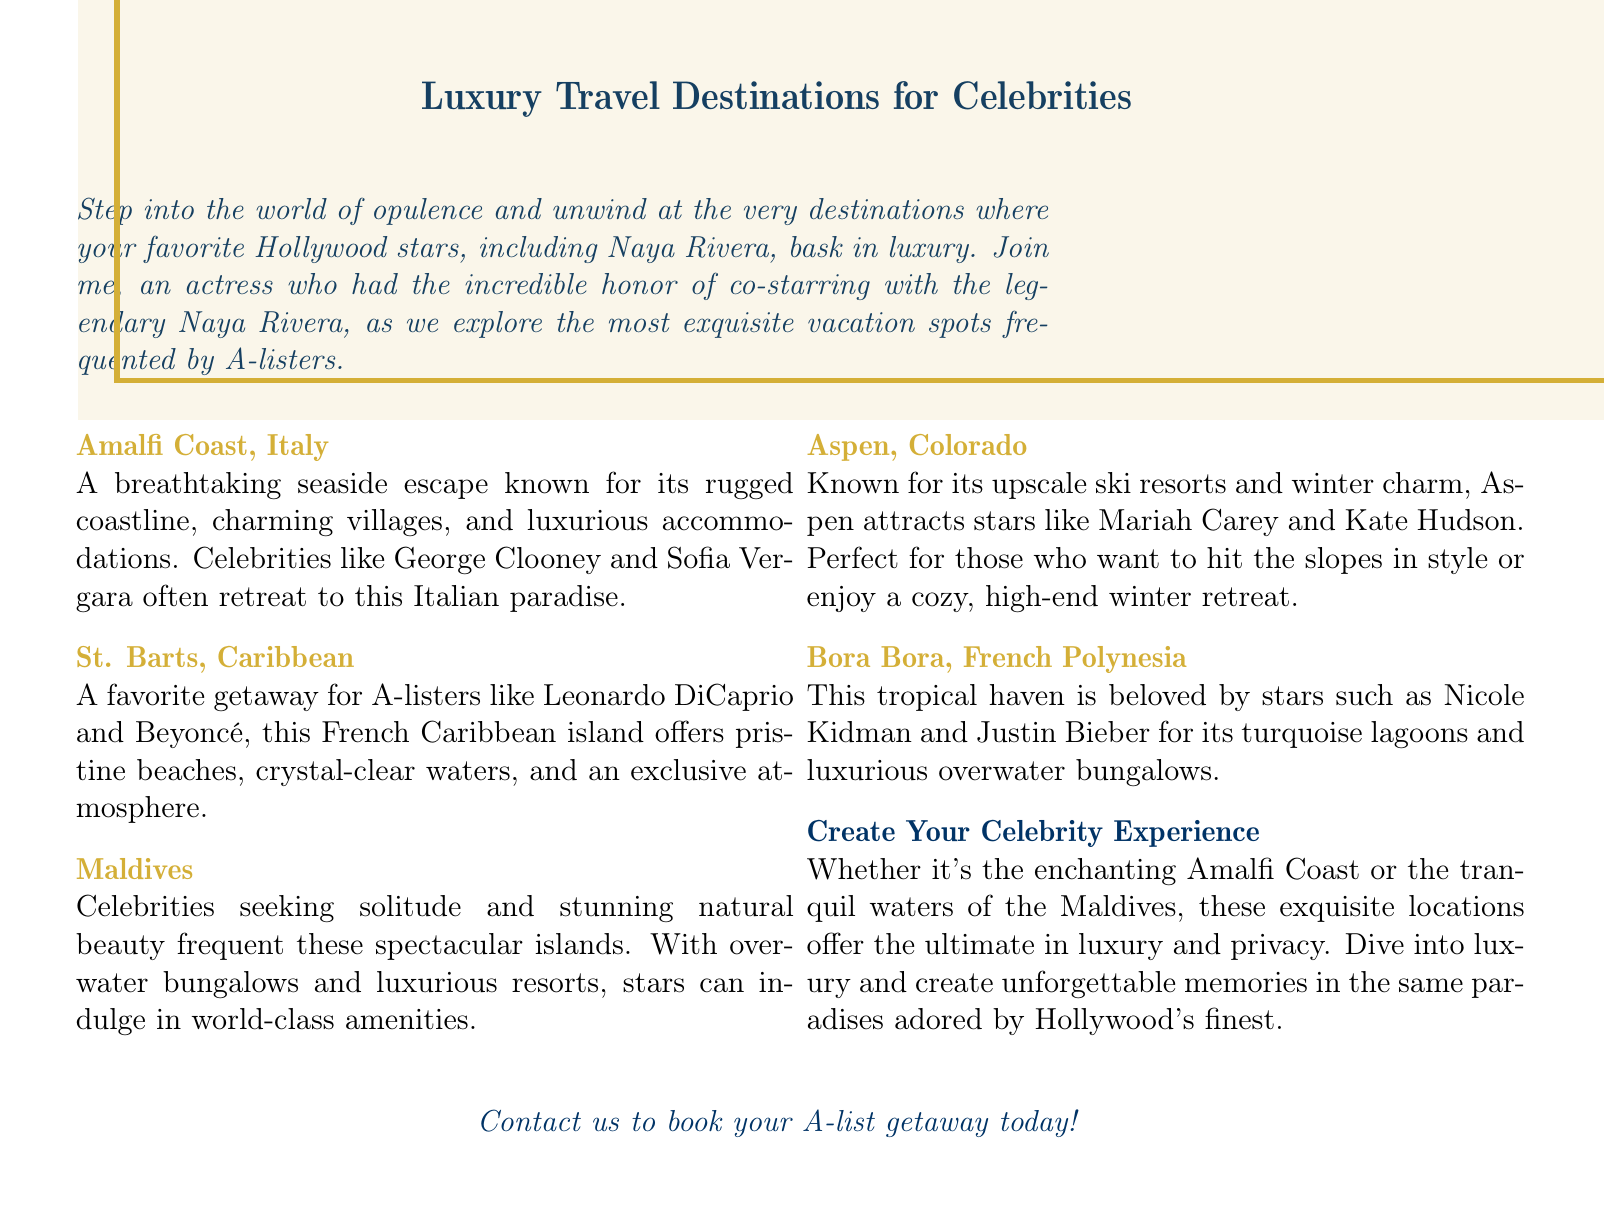What is the title of the advertisement? The title of the advertisement is prominently displayed at the beginning of the document, which is "Luxury Travel Destinations for Celebrities."
Answer: Luxury Travel Destinations for Celebrities Which Italian destination is mentioned? The advertisement specifically mentions "Amalfi Coast, Italy" as an Italian destination.
Answer: Amalfi Coast, Italy Who are two celebrities mentioned that frequent St. Barts? The document lists two celebrities associated with St. Barts, which are Leonardo DiCaprio and Beyoncé.
Answer: Leonardo DiCaprio and Beyoncé What is a leisure activity associated with Aspen? The advertisement indicates that Aspen is associated with skiing, as it is known for its upscale ski resorts.
Answer: Skiing Which luxury destination is favored by Nicole Kidman? The document states that "Bora Bora, French Polynesia" is favored by Nicole Kidman.
Answer: Bora Bora, French Polynesia What type of accommodation is highlighted in the Maldives? The advertisement emphasizes "overwater bungalows" as the type of accommodation in the Maldives.
Answer: Overwater bungalows Which two celebrities are listed as visitors to Amalfi Coast? The document does not specify two celebrities visiting Amalfi Coast but names George Clooney and Sofia Vergara as frequent visitors.
Answer: George Clooney and Sofia Vergara What is the main theme of the advertisement? The main theme of the advertisement revolves around luxury travel destinations frequented by celebrities, highlighting their opulence and exclusiveness.
Answer: Luxury travel destinations What does the document encourage readers to do? The document encourages readers to "book your A-list getaway today," inviting them to contact for booking.
Answer: Book your A-list getaway today 